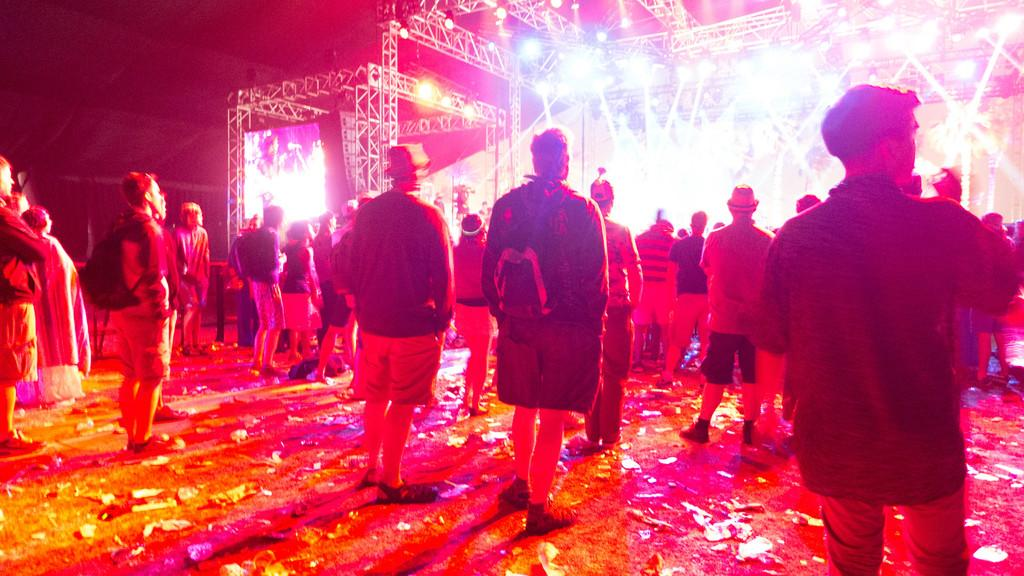What are the people in the image doing? The people in the image are standing on the ground. What can be seen in the background of the image? In the background of the image, there are metal frames, lights, and screens. What is the opinion of the game being played by the people in the image? There is no game being played in the image, and therefore no opinion can be determined. 